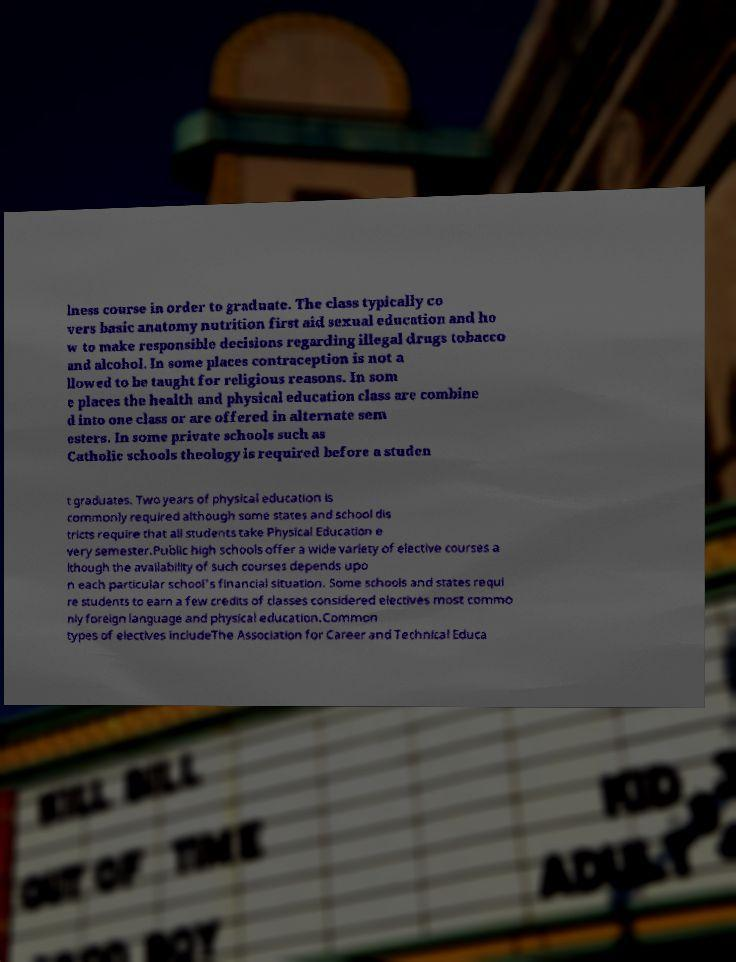For documentation purposes, I need the text within this image transcribed. Could you provide that? lness course in order to graduate. The class typically co vers basic anatomy nutrition first aid sexual education and ho w to make responsible decisions regarding illegal drugs tobacco and alcohol. In some places contraception is not a llowed to be taught for religious reasons. In som e places the health and physical education class are combine d into one class or are offered in alternate sem esters. In some private schools such as Catholic schools theology is required before a studen t graduates. Two years of physical education is commonly required although some states and school dis tricts require that all students take Physical Education e very semester.Public high schools offer a wide variety of elective courses a lthough the availability of such courses depends upo n each particular school's financial situation. Some schools and states requi re students to earn a few credits of classes considered electives most commo nly foreign language and physical education.Common types of electives includeThe Association for Career and Technical Educa 